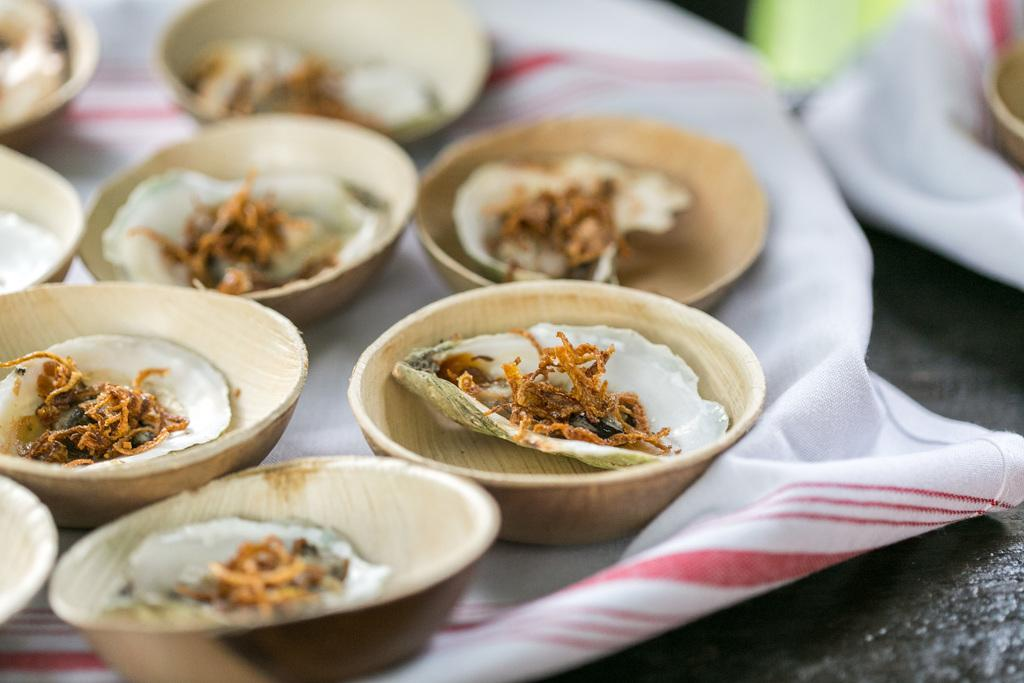What is contained in the cups that are visible in the image? There are food items in cups in the image. What is the surface on which the cups are placed? The cups are on a cloth. Can you describe the background of the image? The background of the image is blurred. What type of square wool can be seen in the image? There is no square wool present in the image. How many bits are visible in the image? There are no bits visible in the image. 